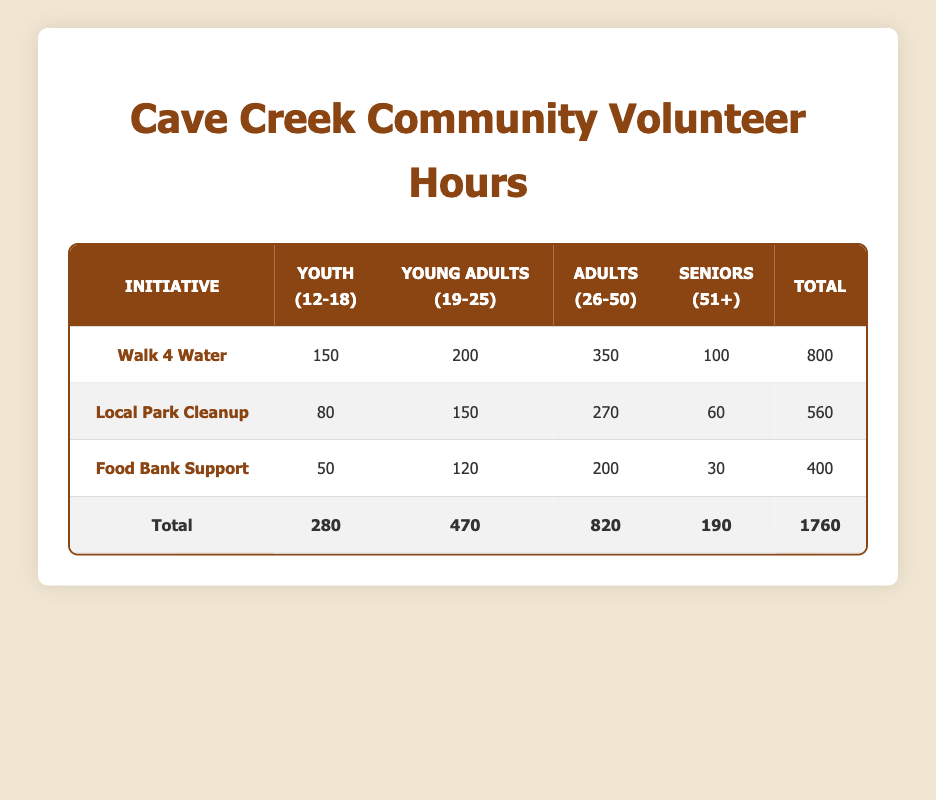What is the total number of volunteer hours contributed to the Walk 4 Water initiative by Youth? The table shows that Youth contributed 150 hours to the Walk 4 Water initiative.
Answer: 150 How many hours did Young Adults contribute to the Local Park Cleanup initiative? According to the table, Young Adults contributed 150 hours to the Local Park Cleanup initiative.
Answer: 150 Which initiative had the highest total volunteer hours? To find the initiative with the highest total, we compare the totals: Walk 4 Water (800), Local Park Cleanup (560), and Food Bank Support (400). Walk 4 Water has the highest total at 800 hours.
Answer: Walk 4 Water Is the total number of hours contributed by Seniors for all initiatives greater than 100? The total hours contributed by Seniors are calculated as: 100 (Walk 4 Water) + 60 (Local Park Cleanup) + 30 (Food Bank Support) = 190. Since 190 is greater than 100, the answer is yes.
Answer: Yes What is the average number of hours contributed by Adults across all three initiatives? To find the average for Adults, we sum their contributions: 350 (Walk 4 Water) + 270 (Local Park Cleanup) + 200 (Food Bank Support) = 820. The average is then 820/3 = approximately 273.33.
Answer: 273.33 Which demographic contributed the least total hours among all initiatives and what was the total? To find the demographic with the least contributions, we calculate the total hours for each: Youth: 280, Young Adults: 470, Adults: 820, Seniors: 190. Seniors contributed the least with a total of 190 hours.
Answer: Seniors, 190 By what percentage did the Adults' contribution to the Walk 4 Water initiative exceed that of Youth's contribution to the same initiative? The difference in hours is: 350 (Adults) - 150 (Youth) = 200. To find the percentage increase, we calculate (200/150) * 100% = approximately 133.33%.
Answer: 133.33% Did the Youth contribute more hours to Food Bank Support than to Local Park Cleanup? Youth contributed 50 hours to Food Bank Support and 80 hours to Local Park Cleanup. Since 80 is greater than 50, the answer is no.
Answer: No What is the combined total of volunteer hours contributed by Young Adults to both Walk 4 Water and Food Bank Support? To find the combined total, we sum the hours: 200 (Walk 4 Water) + 120 (Food Bank Support) = 320 hours.
Answer: 320 